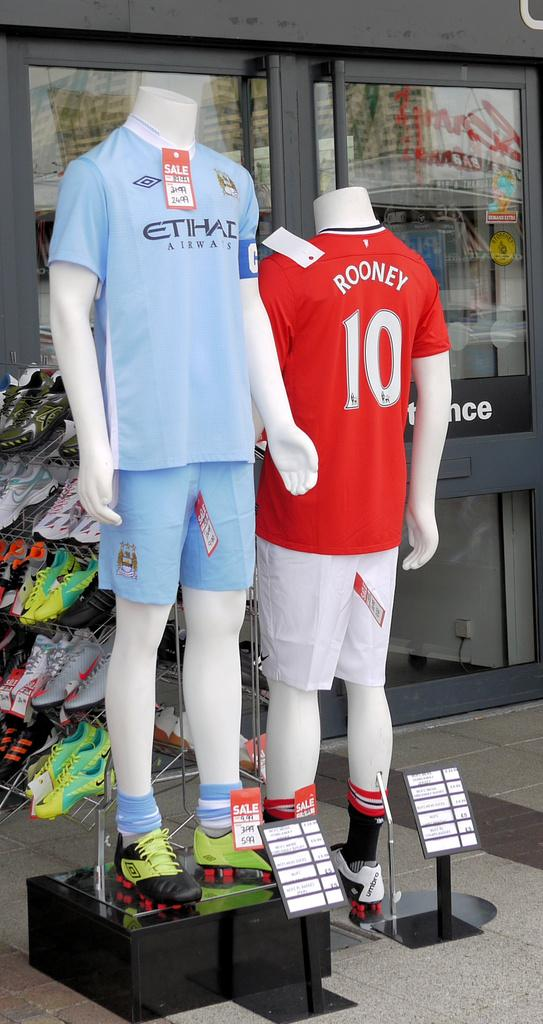<image>
Give a short and clear explanation of the subsequent image. Shirts on display including one that says Rooney 10. 